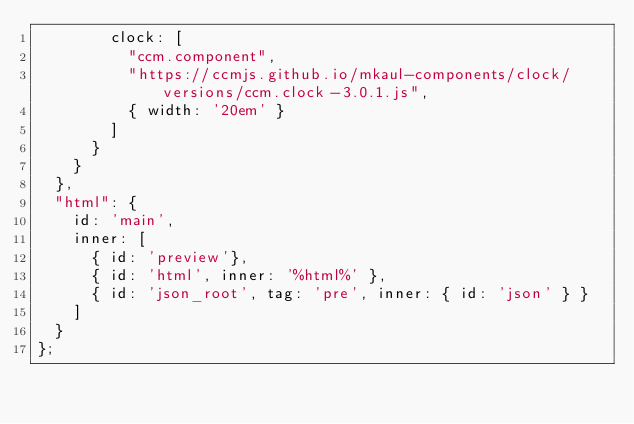<code> <loc_0><loc_0><loc_500><loc_500><_JavaScript_>        clock: [
          "ccm.component",
          "https://ccmjs.github.io/mkaul-components/clock/versions/ccm.clock-3.0.1.js",
          { width: '20em' }
        ]
      }
    }
  },
  "html": {
    id: 'main',
    inner: [
      { id: 'preview'},
      { id: 'html', inner: '%html%' },
      { id: 'json_root', tag: 'pre', inner: { id: 'json' } }
    ]
  }
};
</code> 